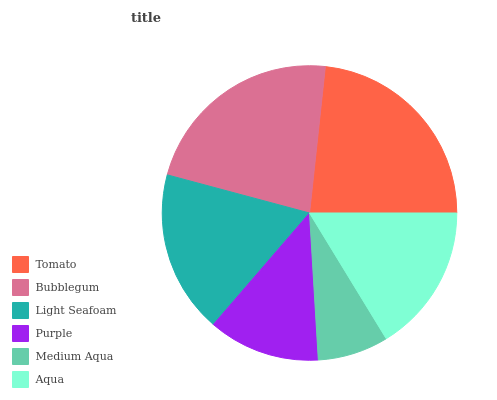Is Medium Aqua the minimum?
Answer yes or no. Yes. Is Tomato the maximum?
Answer yes or no. Yes. Is Bubblegum the minimum?
Answer yes or no. No. Is Bubblegum the maximum?
Answer yes or no. No. Is Tomato greater than Bubblegum?
Answer yes or no. Yes. Is Bubblegum less than Tomato?
Answer yes or no. Yes. Is Bubblegum greater than Tomato?
Answer yes or no. No. Is Tomato less than Bubblegum?
Answer yes or no. No. Is Light Seafoam the high median?
Answer yes or no. Yes. Is Aqua the low median?
Answer yes or no. Yes. Is Purple the high median?
Answer yes or no. No. Is Bubblegum the low median?
Answer yes or no. No. 